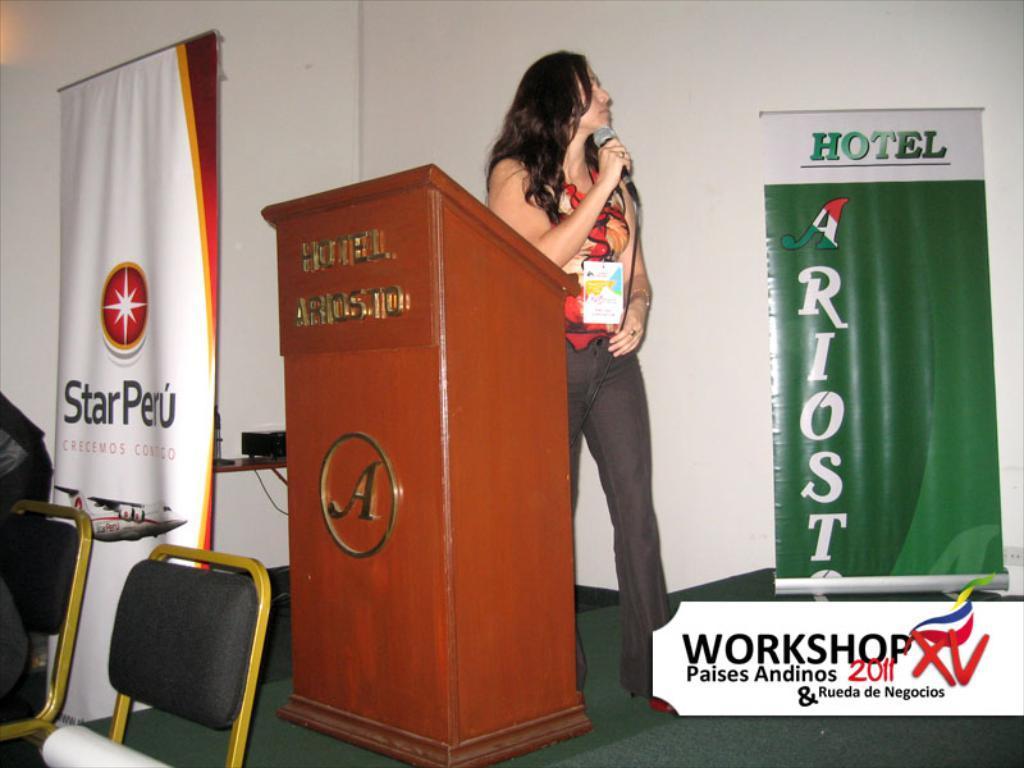Can you describe this image briefly? In this image we can see a woman wearing a dress is holding a microphone in her hand is standing on the stage. In the center of the image we can see a podium with some text on it. On the left side, we can see two chairs and a person, a device placed on the table. In the background we can see two banners with some text. In the bottom we can see the text. 